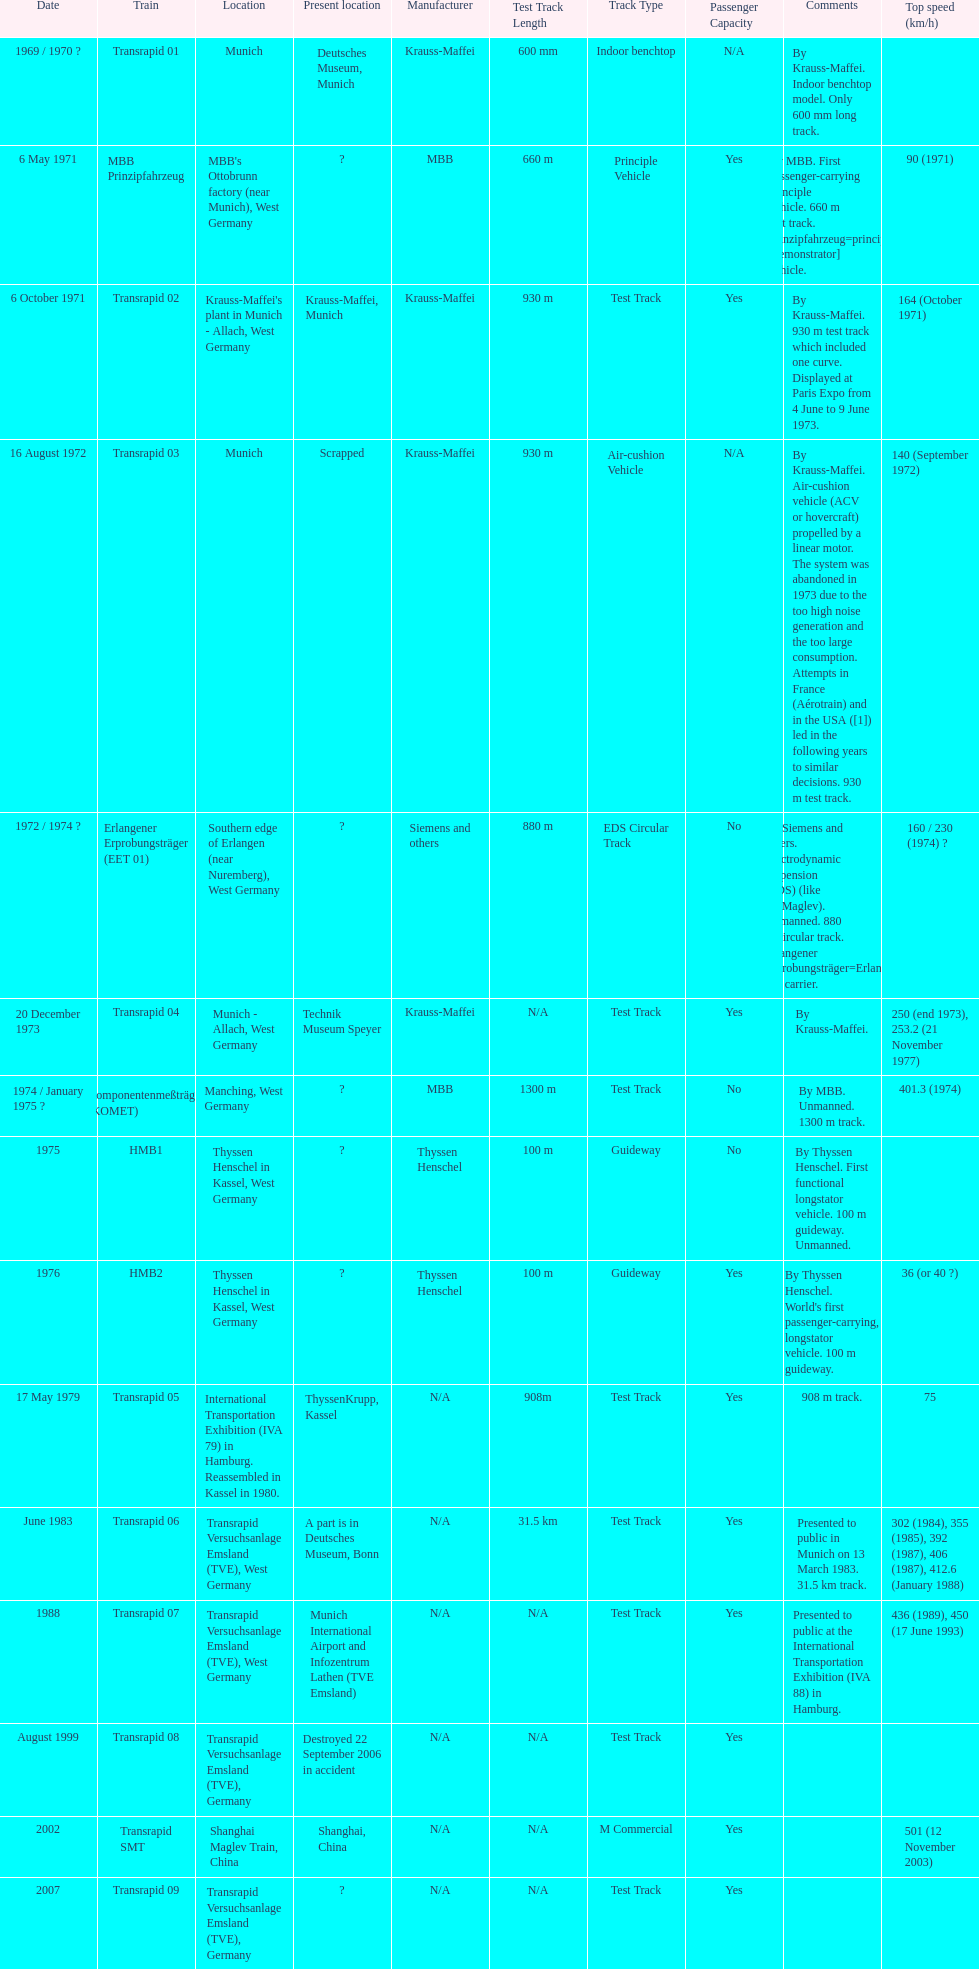What train was abandoned as a result of generating excessive noise and having an overly large consumption? Transrapid 03. 